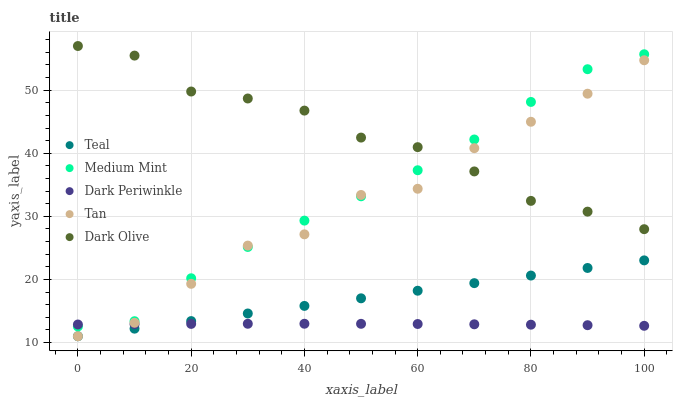Does Dark Periwinkle have the minimum area under the curve?
Answer yes or no. Yes. Does Dark Olive have the maximum area under the curve?
Answer yes or no. Yes. Does Tan have the minimum area under the curve?
Answer yes or no. No. Does Tan have the maximum area under the curve?
Answer yes or no. No. Is Teal the smoothest?
Answer yes or no. Yes. Is Tan the roughest?
Answer yes or no. Yes. Is Dark Olive the smoothest?
Answer yes or no. No. Is Dark Olive the roughest?
Answer yes or no. No. Does Tan have the lowest value?
Answer yes or no. Yes. Does Dark Olive have the lowest value?
Answer yes or no. No. Does Dark Olive have the highest value?
Answer yes or no. Yes. Does Tan have the highest value?
Answer yes or no. No. Is Dark Periwinkle less than Dark Olive?
Answer yes or no. Yes. Is Dark Olive greater than Dark Periwinkle?
Answer yes or no. Yes. Does Dark Olive intersect Tan?
Answer yes or no. Yes. Is Dark Olive less than Tan?
Answer yes or no. No. Is Dark Olive greater than Tan?
Answer yes or no. No. Does Dark Periwinkle intersect Dark Olive?
Answer yes or no. No. 